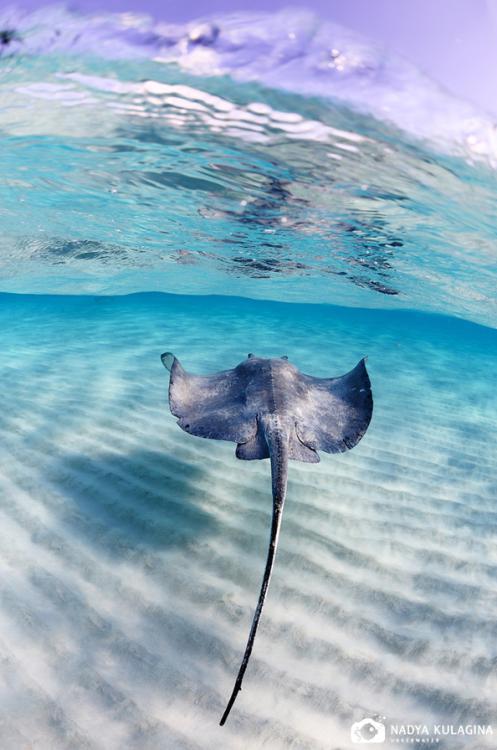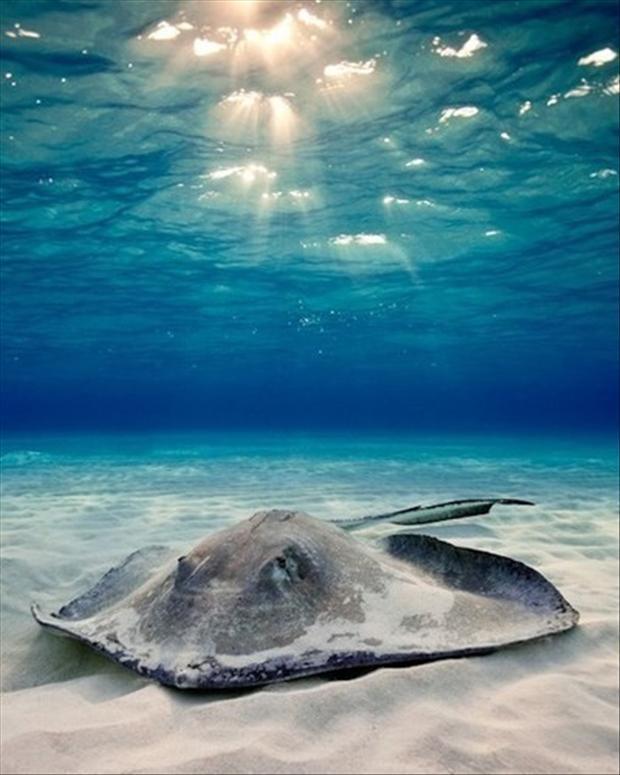The first image is the image on the left, the second image is the image on the right. Evaluate the accuracy of this statement regarding the images: "A single ray is swimming near the sand in the image on the left.". Is it true? Answer yes or no. Yes. The first image is the image on the left, the second image is the image on the right. For the images shown, is this caption "An image shows a mass of jellyfish along with something manmade that moves through the water." true? Answer yes or no. No. 